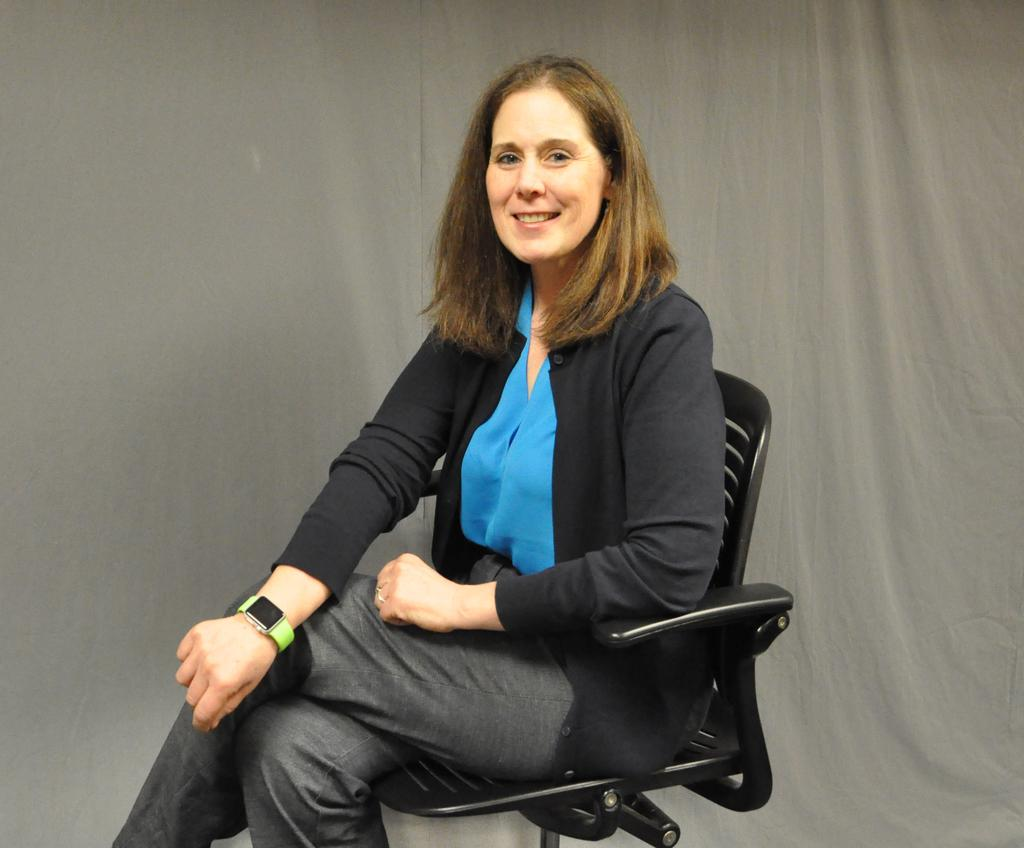Who is the main subject in the image? There is a woman in the image. What is the woman wearing on her upper body? The woman is wearing a blue shirt and a black jacket. What is the woman doing in the image? The woman is sitting on a black chair and smiling. What accessory can be seen on the woman's right hand? There is a watch on the woman's right hand. What can be seen in the background of the image? There is a grey curtain in the background of the image. How many cherries are on the woman's lap in the image? There are no cherries present in the image. What type of brick is used to build the wall behind the woman? There is no wall or brick visible in the image. 